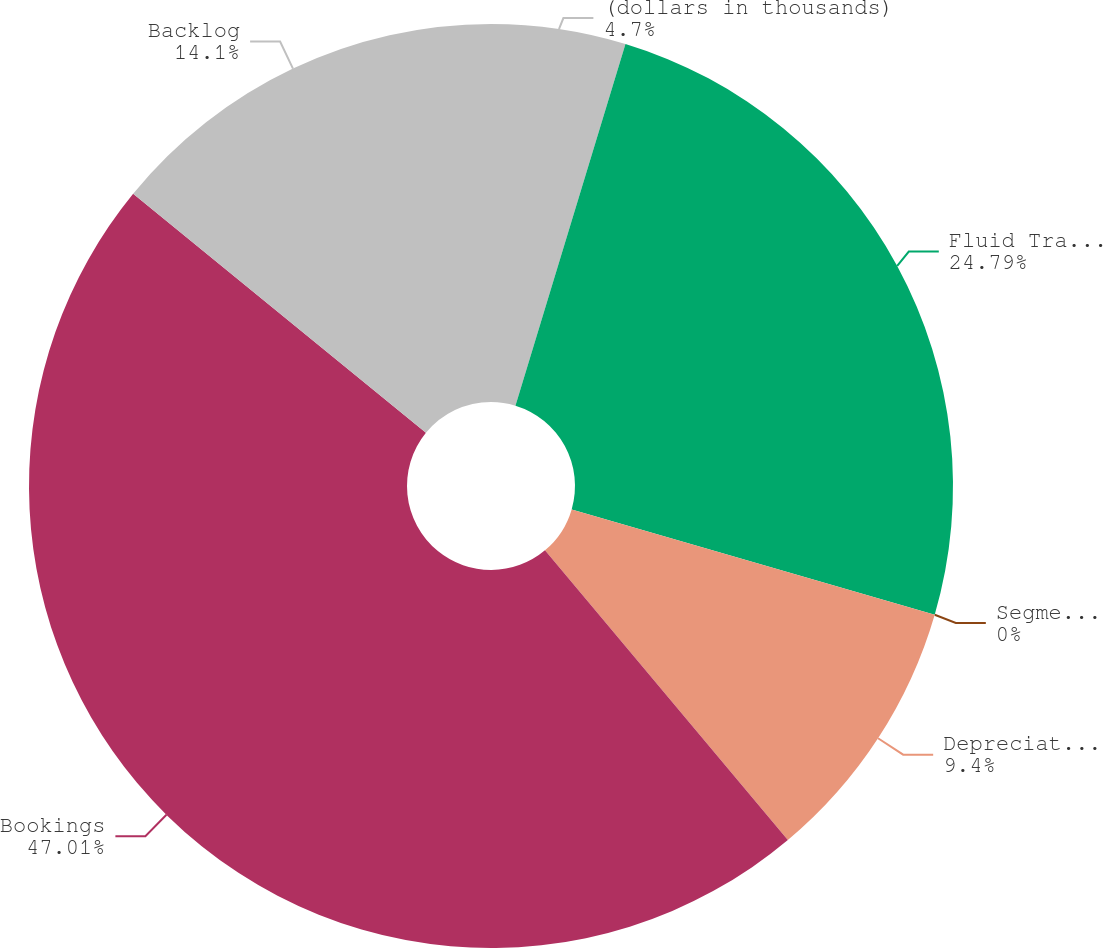Convert chart. <chart><loc_0><loc_0><loc_500><loc_500><pie_chart><fcel>(dollars in thousands)<fcel>Fluid Transfer Pumps<fcel>Segment EBITDA margin<fcel>Depreciation and amortization<fcel>Bookings<fcel>Backlog<nl><fcel>4.7%<fcel>24.79%<fcel>0.0%<fcel>9.4%<fcel>47.0%<fcel>14.1%<nl></chart> 